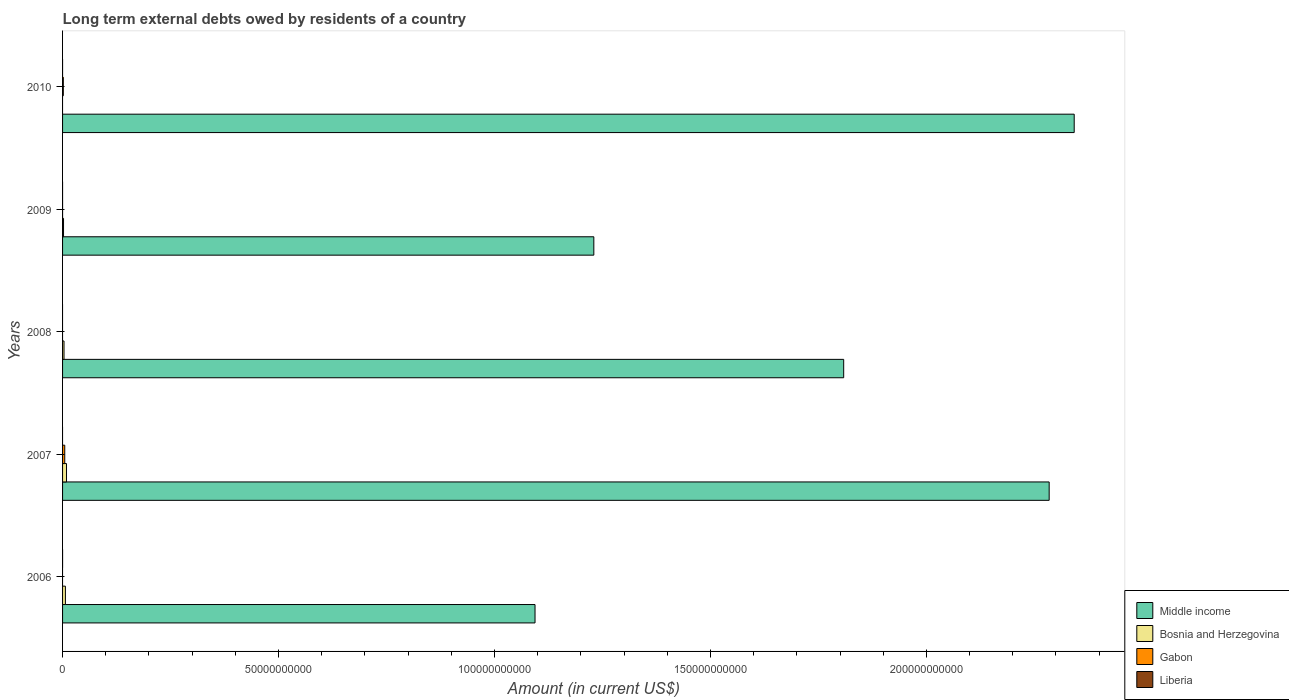How many different coloured bars are there?
Make the answer very short. 3. Are the number of bars per tick equal to the number of legend labels?
Your answer should be very brief. No. Are the number of bars on each tick of the Y-axis equal?
Your answer should be compact. No. How many bars are there on the 4th tick from the bottom?
Give a very brief answer. 3. What is the label of the 5th group of bars from the top?
Make the answer very short. 2006. In how many cases, is the number of bars for a given year not equal to the number of legend labels?
Provide a succinct answer. 5. What is the amount of long-term external debts owed by residents in Middle income in 2009?
Offer a very short reply. 1.23e+11. Across all years, what is the maximum amount of long-term external debts owed by residents in Gabon?
Keep it short and to the point. 5.06e+08. Across all years, what is the minimum amount of long-term external debts owed by residents in Liberia?
Offer a very short reply. 0. In which year was the amount of long-term external debts owed by residents in Bosnia and Herzegovina maximum?
Provide a short and direct response. 2007. What is the total amount of long-term external debts owed by residents in Gabon in the graph?
Provide a short and direct response. 6.81e+08. What is the difference between the amount of long-term external debts owed by residents in Bosnia and Herzegovina in 2007 and that in 2009?
Keep it short and to the point. 6.90e+08. What is the difference between the amount of long-term external debts owed by residents in Gabon in 2008 and the amount of long-term external debts owed by residents in Bosnia and Herzegovina in 2007?
Offer a very short reply. -9.13e+08. What is the average amount of long-term external debts owed by residents in Gabon per year?
Provide a short and direct response. 1.36e+08. In the year 2009, what is the difference between the amount of long-term external debts owed by residents in Bosnia and Herzegovina and amount of long-term external debts owed by residents in Middle income?
Your response must be concise. -1.23e+11. In how many years, is the amount of long-term external debts owed by residents in Gabon greater than 10000000000 US$?
Make the answer very short. 0. What is the ratio of the amount of long-term external debts owed by residents in Bosnia and Herzegovina in 2006 to that in 2009?
Ensure brevity in your answer.  2.94. Is the amount of long-term external debts owed by residents in Gabon in 2007 less than that in 2010?
Provide a short and direct response. No. Is the difference between the amount of long-term external debts owed by residents in Bosnia and Herzegovina in 2006 and 2009 greater than the difference between the amount of long-term external debts owed by residents in Middle income in 2006 and 2009?
Provide a succinct answer. Yes. What is the difference between the highest and the second highest amount of long-term external debts owed by residents in Gabon?
Your response must be concise. 3.31e+08. What is the difference between the highest and the lowest amount of long-term external debts owed by residents in Middle income?
Your answer should be compact. 1.25e+11. In how many years, is the amount of long-term external debts owed by residents in Liberia greater than the average amount of long-term external debts owed by residents in Liberia taken over all years?
Offer a terse response. 0. Is the sum of the amount of long-term external debts owed by residents in Bosnia and Herzegovina in 2006 and 2007 greater than the maximum amount of long-term external debts owed by residents in Gabon across all years?
Your answer should be compact. Yes. Is it the case that in every year, the sum of the amount of long-term external debts owed by residents in Bosnia and Herzegovina and amount of long-term external debts owed by residents in Middle income is greater than the sum of amount of long-term external debts owed by residents in Liberia and amount of long-term external debts owed by residents in Gabon?
Offer a very short reply. No. How many bars are there?
Give a very brief answer. 12. Are all the bars in the graph horizontal?
Ensure brevity in your answer.  Yes. How many years are there in the graph?
Give a very brief answer. 5. What is the difference between two consecutive major ticks on the X-axis?
Provide a succinct answer. 5.00e+1. Are the values on the major ticks of X-axis written in scientific E-notation?
Offer a very short reply. No. Does the graph contain any zero values?
Provide a succinct answer. Yes. Where does the legend appear in the graph?
Make the answer very short. Bottom right. How are the legend labels stacked?
Keep it short and to the point. Vertical. What is the title of the graph?
Provide a short and direct response. Long term external debts owed by residents of a country. What is the Amount (in current US$) of Middle income in 2006?
Your answer should be compact. 1.09e+11. What is the Amount (in current US$) in Bosnia and Herzegovina in 2006?
Offer a terse response. 6.58e+08. What is the Amount (in current US$) in Liberia in 2006?
Your answer should be very brief. 0. What is the Amount (in current US$) in Middle income in 2007?
Give a very brief answer. 2.28e+11. What is the Amount (in current US$) in Bosnia and Herzegovina in 2007?
Your answer should be compact. 9.13e+08. What is the Amount (in current US$) in Gabon in 2007?
Keep it short and to the point. 5.06e+08. What is the Amount (in current US$) in Liberia in 2007?
Provide a short and direct response. 0. What is the Amount (in current US$) in Middle income in 2008?
Provide a succinct answer. 1.81e+11. What is the Amount (in current US$) in Bosnia and Herzegovina in 2008?
Your answer should be very brief. 3.35e+08. What is the Amount (in current US$) in Gabon in 2008?
Provide a short and direct response. 0. What is the Amount (in current US$) of Middle income in 2009?
Keep it short and to the point. 1.23e+11. What is the Amount (in current US$) of Bosnia and Herzegovina in 2009?
Give a very brief answer. 2.23e+08. What is the Amount (in current US$) in Gabon in 2009?
Provide a short and direct response. 2.35e+05. What is the Amount (in current US$) of Middle income in 2010?
Give a very brief answer. 2.34e+11. What is the Amount (in current US$) of Gabon in 2010?
Make the answer very short. 1.75e+08. What is the Amount (in current US$) of Liberia in 2010?
Provide a short and direct response. 0. Across all years, what is the maximum Amount (in current US$) of Middle income?
Your answer should be very brief. 2.34e+11. Across all years, what is the maximum Amount (in current US$) in Bosnia and Herzegovina?
Keep it short and to the point. 9.13e+08. Across all years, what is the maximum Amount (in current US$) of Gabon?
Your response must be concise. 5.06e+08. Across all years, what is the minimum Amount (in current US$) of Middle income?
Provide a short and direct response. 1.09e+11. What is the total Amount (in current US$) of Middle income in the graph?
Your answer should be compact. 8.76e+11. What is the total Amount (in current US$) in Bosnia and Herzegovina in the graph?
Provide a succinct answer. 2.13e+09. What is the total Amount (in current US$) in Gabon in the graph?
Ensure brevity in your answer.  6.81e+08. What is the total Amount (in current US$) in Liberia in the graph?
Keep it short and to the point. 0. What is the difference between the Amount (in current US$) in Middle income in 2006 and that in 2007?
Provide a short and direct response. -1.19e+11. What is the difference between the Amount (in current US$) in Bosnia and Herzegovina in 2006 and that in 2007?
Ensure brevity in your answer.  -2.56e+08. What is the difference between the Amount (in current US$) in Middle income in 2006 and that in 2008?
Offer a very short reply. -7.15e+1. What is the difference between the Amount (in current US$) of Bosnia and Herzegovina in 2006 and that in 2008?
Make the answer very short. 3.23e+08. What is the difference between the Amount (in current US$) of Middle income in 2006 and that in 2009?
Your answer should be compact. -1.36e+1. What is the difference between the Amount (in current US$) in Bosnia and Herzegovina in 2006 and that in 2009?
Keep it short and to the point. 4.34e+08. What is the difference between the Amount (in current US$) of Middle income in 2006 and that in 2010?
Ensure brevity in your answer.  -1.25e+11. What is the difference between the Amount (in current US$) of Middle income in 2007 and that in 2008?
Your answer should be compact. 4.76e+1. What is the difference between the Amount (in current US$) of Bosnia and Herzegovina in 2007 and that in 2008?
Provide a succinct answer. 5.79e+08. What is the difference between the Amount (in current US$) of Middle income in 2007 and that in 2009?
Give a very brief answer. 1.05e+11. What is the difference between the Amount (in current US$) in Bosnia and Herzegovina in 2007 and that in 2009?
Make the answer very short. 6.90e+08. What is the difference between the Amount (in current US$) of Gabon in 2007 and that in 2009?
Offer a terse response. 5.06e+08. What is the difference between the Amount (in current US$) in Middle income in 2007 and that in 2010?
Make the answer very short. -5.80e+09. What is the difference between the Amount (in current US$) in Gabon in 2007 and that in 2010?
Offer a terse response. 3.31e+08. What is the difference between the Amount (in current US$) of Middle income in 2008 and that in 2009?
Your response must be concise. 5.78e+1. What is the difference between the Amount (in current US$) of Bosnia and Herzegovina in 2008 and that in 2009?
Provide a succinct answer. 1.11e+08. What is the difference between the Amount (in current US$) of Middle income in 2008 and that in 2010?
Keep it short and to the point. -5.34e+1. What is the difference between the Amount (in current US$) in Middle income in 2009 and that in 2010?
Offer a very short reply. -1.11e+11. What is the difference between the Amount (in current US$) in Gabon in 2009 and that in 2010?
Make the answer very short. -1.74e+08. What is the difference between the Amount (in current US$) in Middle income in 2006 and the Amount (in current US$) in Bosnia and Herzegovina in 2007?
Ensure brevity in your answer.  1.08e+11. What is the difference between the Amount (in current US$) in Middle income in 2006 and the Amount (in current US$) in Gabon in 2007?
Make the answer very short. 1.09e+11. What is the difference between the Amount (in current US$) of Bosnia and Herzegovina in 2006 and the Amount (in current US$) of Gabon in 2007?
Provide a short and direct response. 1.52e+08. What is the difference between the Amount (in current US$) of Middle income in 2006 and the Amount (in current US$) of Bosnia and Herzegovina in 2008?
Offer a terse response. 1.09e+11. What is the difference between the Amount (in current US$) in Middle income in 2006 and the Amount (in current US$) in Bosnia and Herzegovina in 2009?
Your response must be concise. 1.09e+11. What is the difference between the Amount (in current US$) of Middle income in 2006 and the Amount (in current US$) of Gabon in 2009?
Keep it short and to the point. 1.09e+11. What is the difference between the Amount (in current US$) of Bosnia and Herzegovina in 2006 and the Amount (in current US$) of Gabon in 2009?
Offer a terse response. 6.57e+08. What is the difference between the Amount (in current US$) of Middle income in 2006 and the Amount (in current US$) of Gabon in 2010?
Your response must be concise. 1.09e+11. What is the difference between the Amount (in current US$) in Bosnia and Herzegovina in 2006 and the Amount (in current US$) in Gabon in 2010?
Make the answer very short. 4.83e+08. What is the difference between the Amount (in current US$) of Middle income in 2007 and the Amount (in current US$) of Bosnia and Herzegovina in 2008?
Make the answer very short. 2.28e+11. What is the difference between the Amount (in current US$) of Middle income in 2007 and the Amount (in current US$) of Bosnia and Herzegovina in 2009?
Provide a short and direct response. 2.28e+11. What is the difference between the Amount (in current US$) of Middle income in 2007 and the Amount (in current US$) of Gabon in 2009?
Your answer should be very brief. 2.28e+11. What is the difference between the Amount (in current US$) of Bosnia and Herzegovina in 2007 and the Amount (in current US$) of Gabon in 2009?
Make the answer very short. 9.13e+08. What is the difference between the Amount (in current US$) in Middle income in 2007 and the Amount (in current US$) in Gabon in 2010?
Make the answer very short. 2.28e+11. What is the difference between the Amount (in current US$) of Bosnia and Herzegovina in 2007 and the Amount (in current US$) of Gabon in 2010?
Provide a succinct answer. 7.39e+08. What is the difference between the Amount (in current US$) in Middle income in 2008 and the Amount (in current US$) in Bosnia and Herzegovina in 2009?
Give a very brief answer. 1.81e+11. What is the difference between the Amount (in current US$) in Middle income in 2008 and the Amount (in current US$) in Gabon in 2009?
Give a very brief answer. 1.81e+11. What is the difference between the Amount (in current US$) in Bosnia and Herzegovina in 2008 and the Amount (in current US$) in Gabon in 2009?
Make the answer very short. 3.35e+08. What is the difference between the Amount (in current US$) of Middle income in 2008 and the Amount (in current US$) of Gabon in 2010?
Your answer should be very brief. 1.81e+11. What is the difference between the Amount (in current US$) of Bosnia and Herzegovina in 2008 and the Amount (in current US$) of Gabon in 2010?
Make the answer very short. 1.60e+08. What is the difference between the Amount (in current US$) of Middle income in 2009 and the Amount (in current US$) of Gabon in 2010?
Provide a succinct answer. 1.23e+11. What is the difference between the Amount (in current US$) of Bosnia and Herzegovina in 2009 and the Amount (in current US$) of Gabon in 2010?
Provide a short and direct response. 4.87e+07. What is the average Amount (in current US$) in Middle income per year?
Your answer should be compact. 1.75e+11. What is the average Amount (in current US$) of Bosnia and Herzegovina per year?
Your response must be concise. 4.26e+08. What is the average Amount (in current US$) in Gabon per year?
Ensure brevity in your answer.  1.36e+08. In the year 2006, what is the difference between the Amount (in current US$) of Middle income and Amount (in current US$) of Bosnia and Herzegovina?
Provide a succinct answer. 1.09e+11. In the year 2007, what is the difference between the Amount (in current US$) of Middle income and Amount (in current US$) of Bosnia and Herzegovina?
Provide a succinct answer. 2.28e+11. In the year 2007, what is the difference between the Amount (in current US$) of Middle income and Amount (in current US$) of Gabon?
Provide a short and direct response. 2.28e+11. In the year 2007, what is the difference between the Amount (in current US$) of Bosnia and Herzegovina and Amount (in current US$) of Gabon?
Offer a terse response. 4.07e+08. In the year 2008, what is the difference between the Amount (in current US$) in Middle income and Amount (in current US$) in Bosnia and Herzegovina?
Your response must be concise. 1.81e+11. In the year 2009, what is the difference between the Amount (in current US$) in Middle income and Amount (in current US$) in Bosnia and Herzegovina?
Offer a terse response. 1.23e+11. In the year 2009, what is the difference between the Amount (in current US$) of Middle income and Amount (in current US$) of Gabon?
Your response must be concise. 1.23e+11. In the year 2009, what is the difference between the Amount (in current US$) of Bosnia and Herzegovina and Amount (in current US$) of Gabon?
Offer a terse response. 2.23e+08. In the year 2010, what is the difference between the Amount (in current US$) in Middle income and Amount (in current US$) in Gabon?
Your response must be concise. 2.34e+11. What is the ratio of the Amount (in current US$) in Middle income in 2006 to that in 2007?
Your response must be concise. 0.48. What is the ratio of the Amount (in current US$) of Bosnia and Herzegovina in 2006 to that in 2007?
Keep it short and to the point. 0.72. What is the ratio of the Amount (in current US$) in Middle income in 2006 to that in 2008?
Offer a very short reply. 0.6. What is the ratio of the Amount (in current US$) in Bosnia and Herzegovina in 2006 to that in 2008?
Offer a very short reply. 1.96. What is the ratio of the Amount (in current US$) of Middle income in 2006 to that in 2009?
Your response must be concise. 0.89. What is the ratio of the Amount (in current US$) of Bosnia and Herzegovina in 2006 to that in 2009?
Make the answer very short. 2.94. What is the ratio of the Amount (in current US$) of Middle income in 2006 to that in 2010?
Ensure brevity in your answer.  0.47. What is the ratio of the Amount (in current US$) of Middle income in 2007 to that in 2008?
Make the answer very short. 1.26. What is the ratio of the Amount (in current US$) in Bosnia and Herzegovina in 2007 to that in 2008?
Your answer should be compact. 2.73. What is the ratio of the Amount (in current US$) in Middle income in 2007 to that in 2009?
Your answer should be compact. 1.86. What is the ratio of the Amount (in current US$) in Bosnia and Herzegovina in 2007 to that in 2009?
Provide a succinct answer. 4.09. What is the ratio of the Amount (in current US$) in Gabon in 2007 to that in 2009?
Provide a succinct answer. 2153.56. What is the ratio of the Amount (in current US$) in Middle income in 2007 to that in 2010?
Give a very brief answer. 0.98. What is the ratio of the Amount (in current US$) in Gabon in 2007 to that in 2010?
Offer a very short reply. 2.9. What is the ratio of the Amount (in current US$) in Middle income in 2008 to that in 2009?
Give a very brief answer. 1.47. What is the ratio of the Amount (in current US$) in Bosnia and Herzegovina in 2008 to that in 2009?
Your answer should be compact. 1.5. What is the ratio of the Amount (in current US$) in Middle income in 2008 to that in 2010?
Your answer should be very brief. 0.77. What is the ratio of the Amount (in current US$) of Middle income in 2009 to that in 2010?
Give a very brief answer. 0.53. What is the ratio of the Amount (in current US$) of Gabon in 2009 to that in 2010?
Make the answer very short. 0. What is the difference between the highest and the second highest Amount (in current US$) in Middle income?
Give a very brief answer. 5.80e+09. What is the difference between the highest and the second highest Amount (in current US$) of Bosnia and Herzegovina?
Make the answer very short. 2.56e+08. What is the difference between the highest and the second highest Amount (in current US$) in Gabon?
Your answer should be compact. 3.31e+08. What is the difference between the highest and the lowest Amount (in current US$) in Middle income?
Make the answer very short. 1.25e+11. What is the difference between the highest and the lowest Amount (in current US$) in Bosnia and Herzegovina?
Give a very brief answer. 9.13e+08. What is the difference between the highest and the lowest Amount (in current US$) of Gabon?
Your response must be concise. 5.06e+08. 